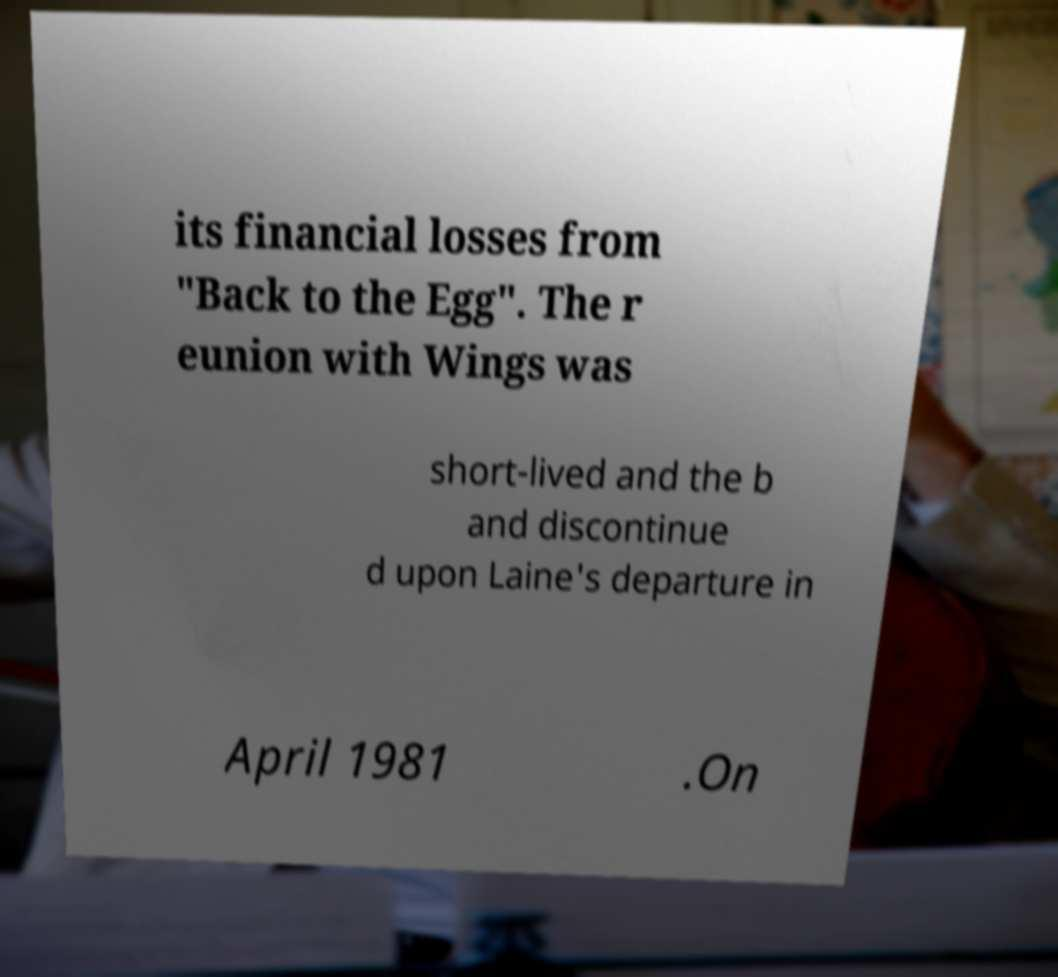Can you read and provide the text displayed in the image?This photo seems to have some interesting text. Can you extract and type it out for me? its financial losses from "Back to the Egg". The r eunion with Wings was short-lived and the b and discontinue d upon Laine's departure in April 1981 .On 